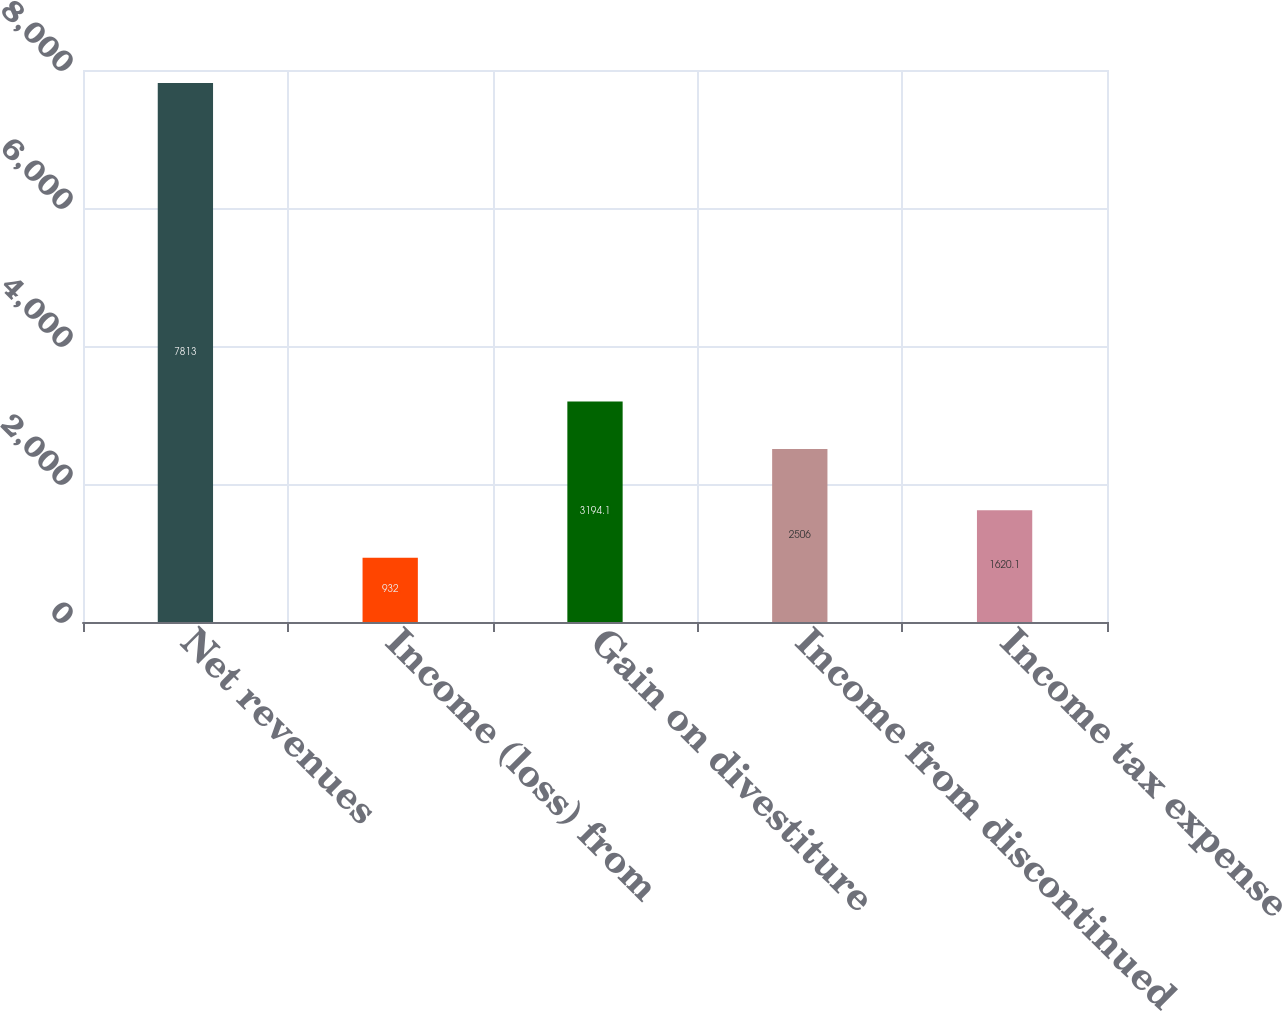Convert chart to OTSL. <chart><loc_0><loc_0><loc_500><loc_500><bar_chart><fcel>Net revenues<fcel>Income (loss) from<fcel>Gain on divestiture<fcel>Income from discontinued<fcel>Income tax expense<nl><fcel>7813<fcel>932<fcel>3194.1<fcel>2506<fcel>1620.1<nl></chart> 